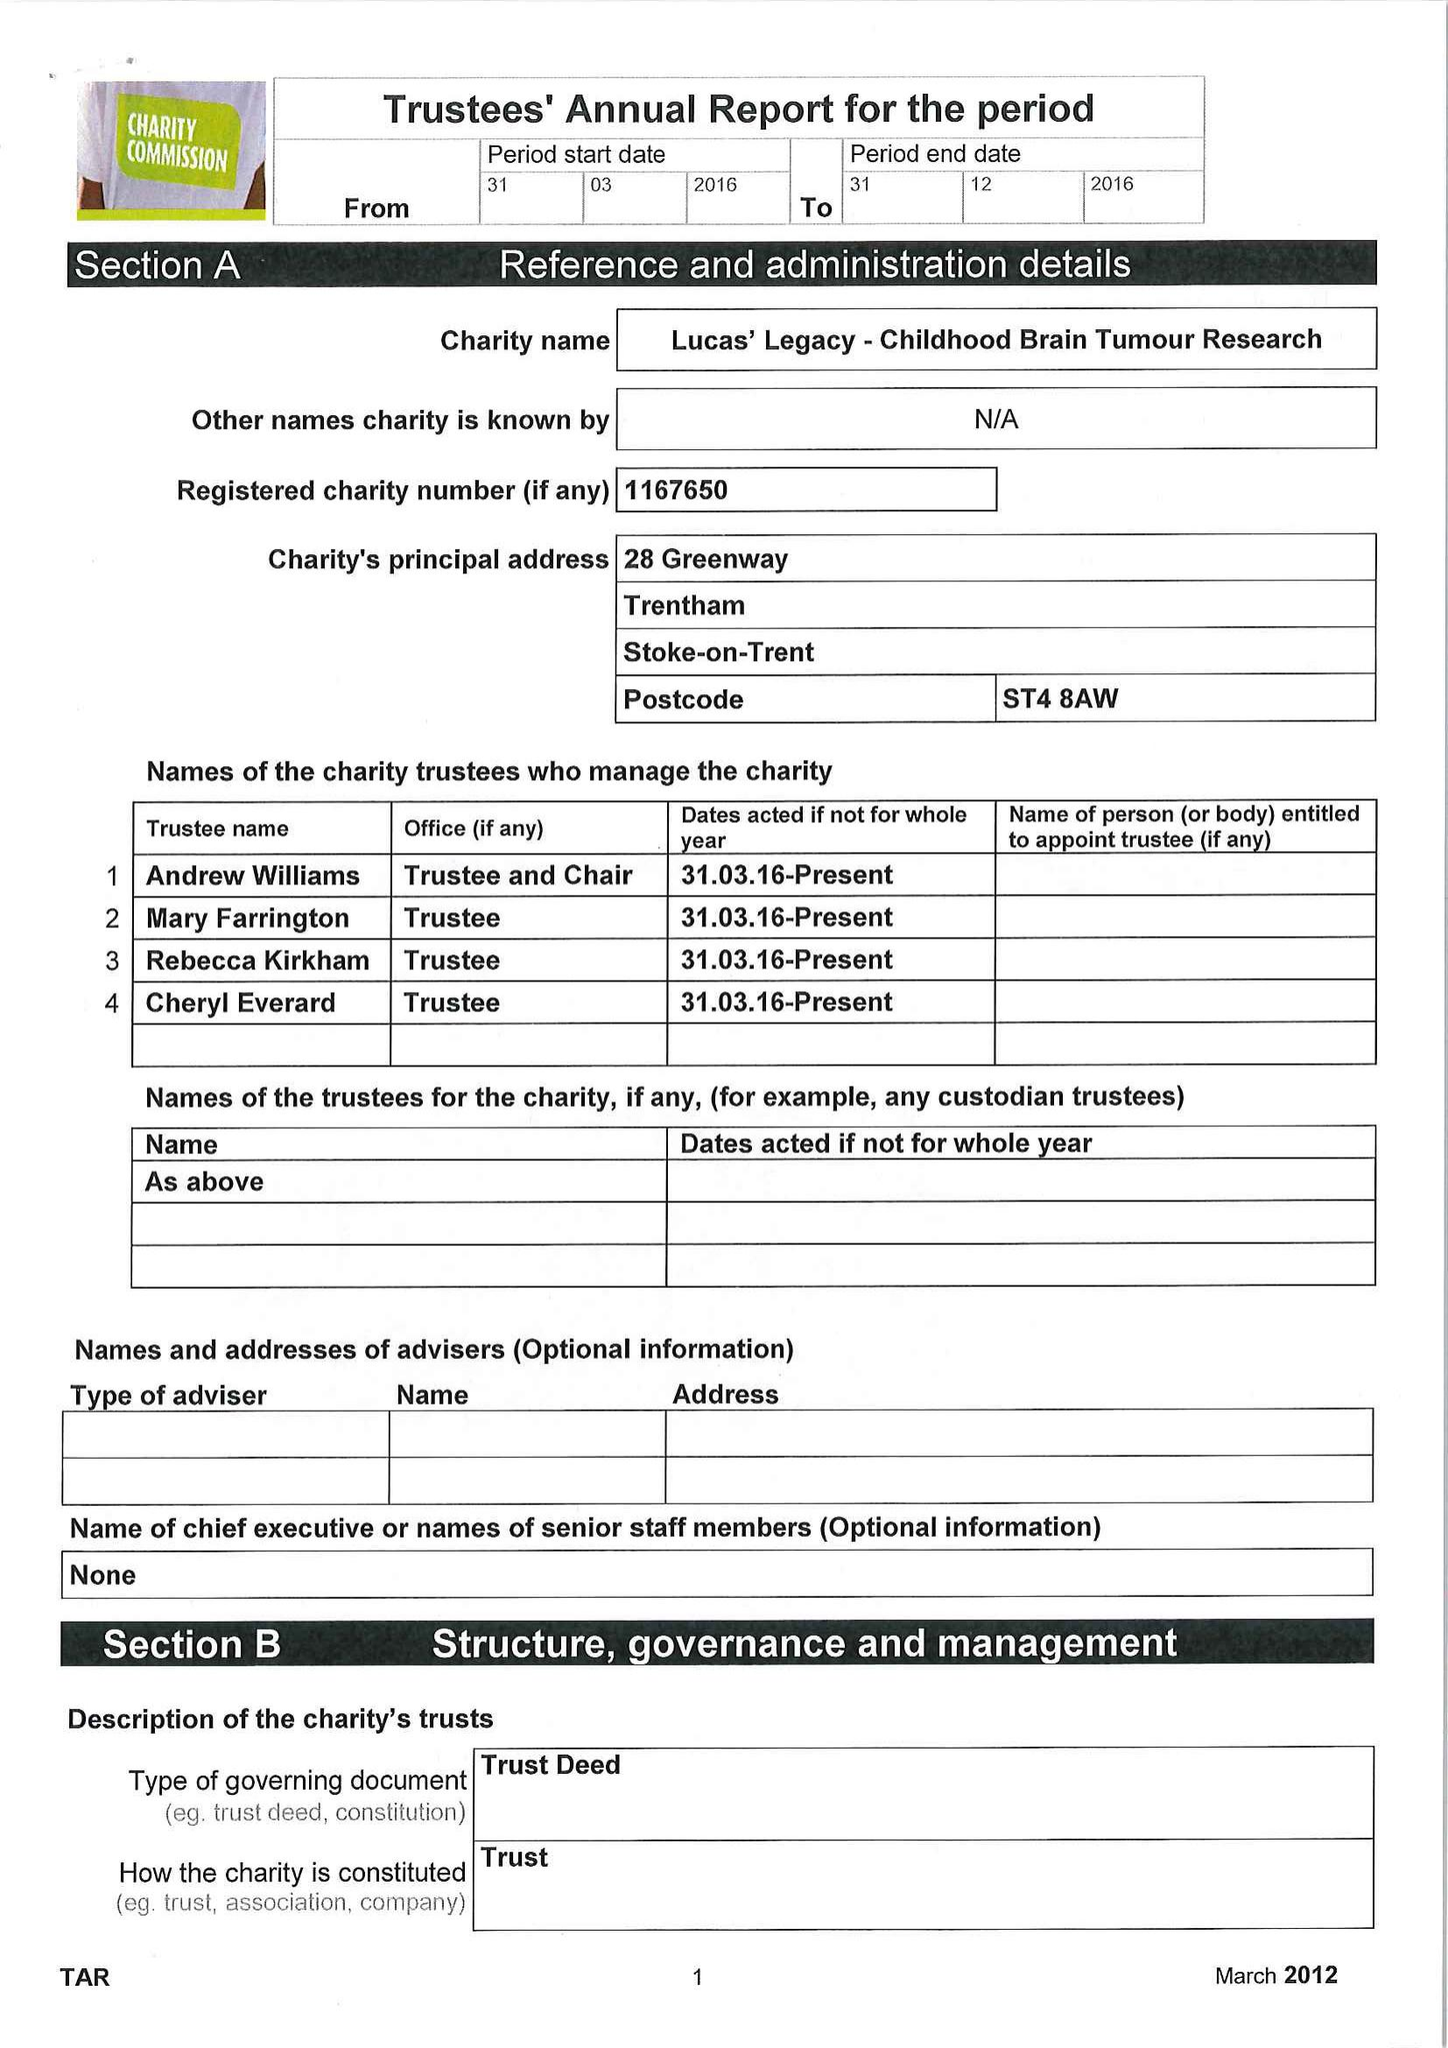What is the value for the address__post_town?
Answer the question using a single word or phrase. STOKE-ON-TRENT 